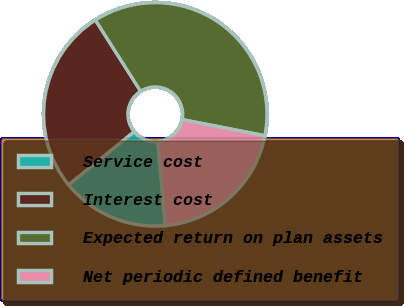Convert chart. <chart><loc_0><loc_0><loc_500><loc_500><pie_chart><fcel>Service cost<fcel>Interest cost<fcel>Expected return on plan assets<fcel>Net periodic defined benefit<nl><fcel>15.59%<fcel>26.85%<fcel>37.07%<fcel>20.49%<nl></chart> 